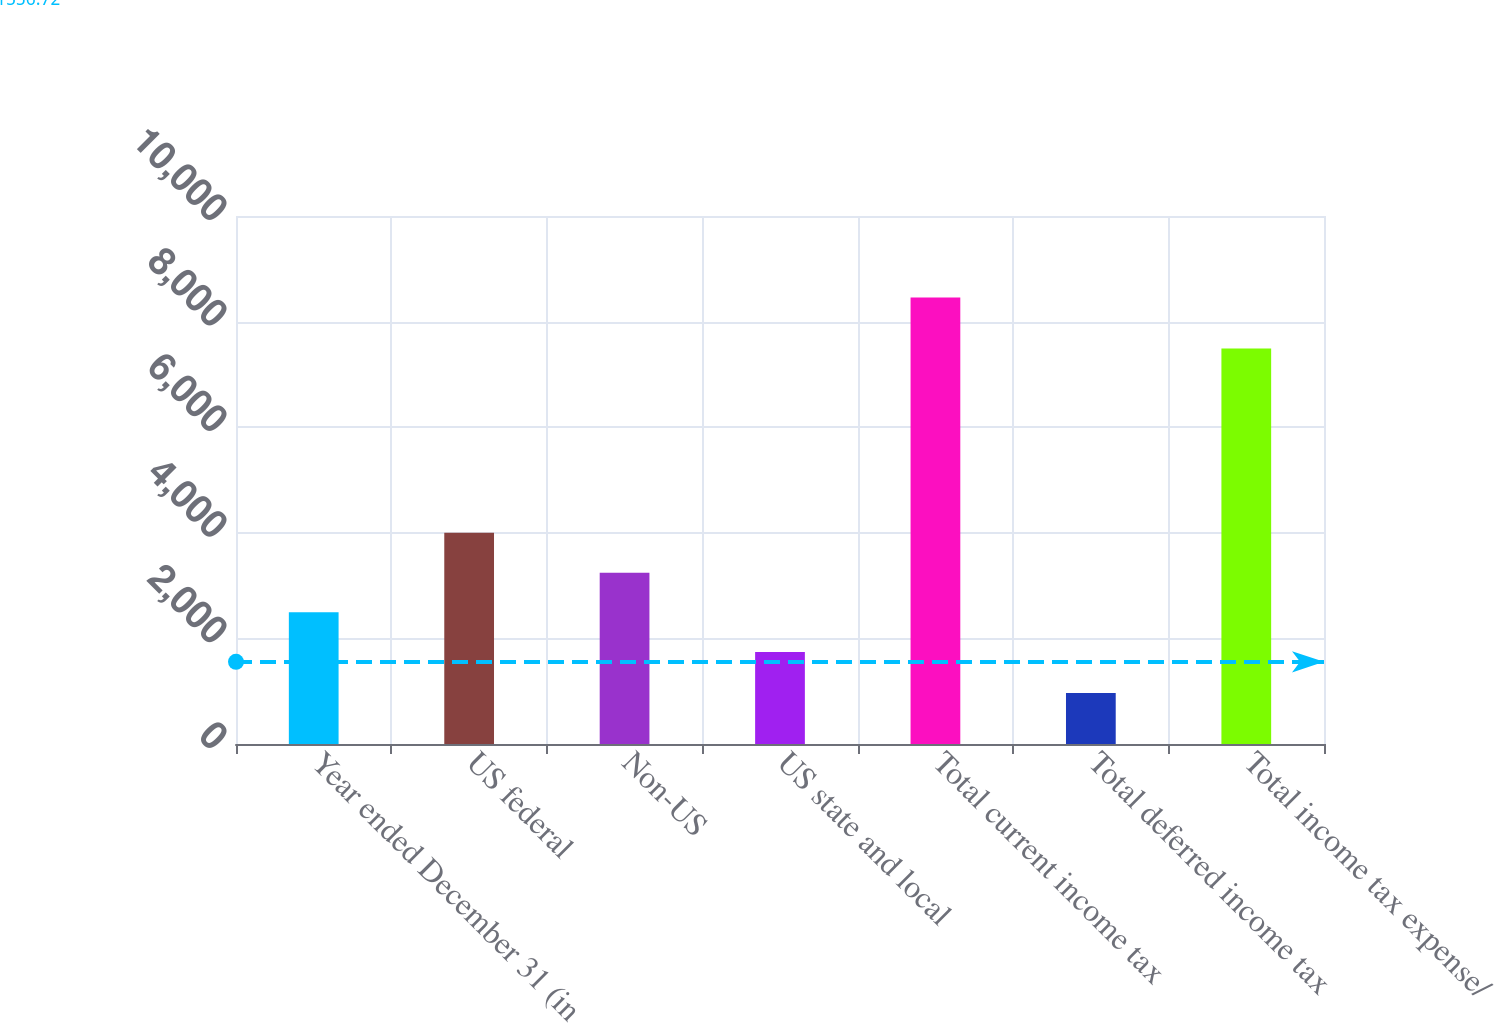Convert chart. <chart><loc_0><loc_0><loc_500><loc_500><bar_chart><fcel>Year ended December 31 (in<fcel>US federal<fcel>Non-US<fcel>US state and local<fcel>Total current income tax<fcel>Total deferred income tax<fcel>Total income tax expense/<nl><fcel>2492.9<fcel>4001<fcel>3241.8<fcel>1744<fcel>8457<fcel>968<fcel>7489<nl></chart> 